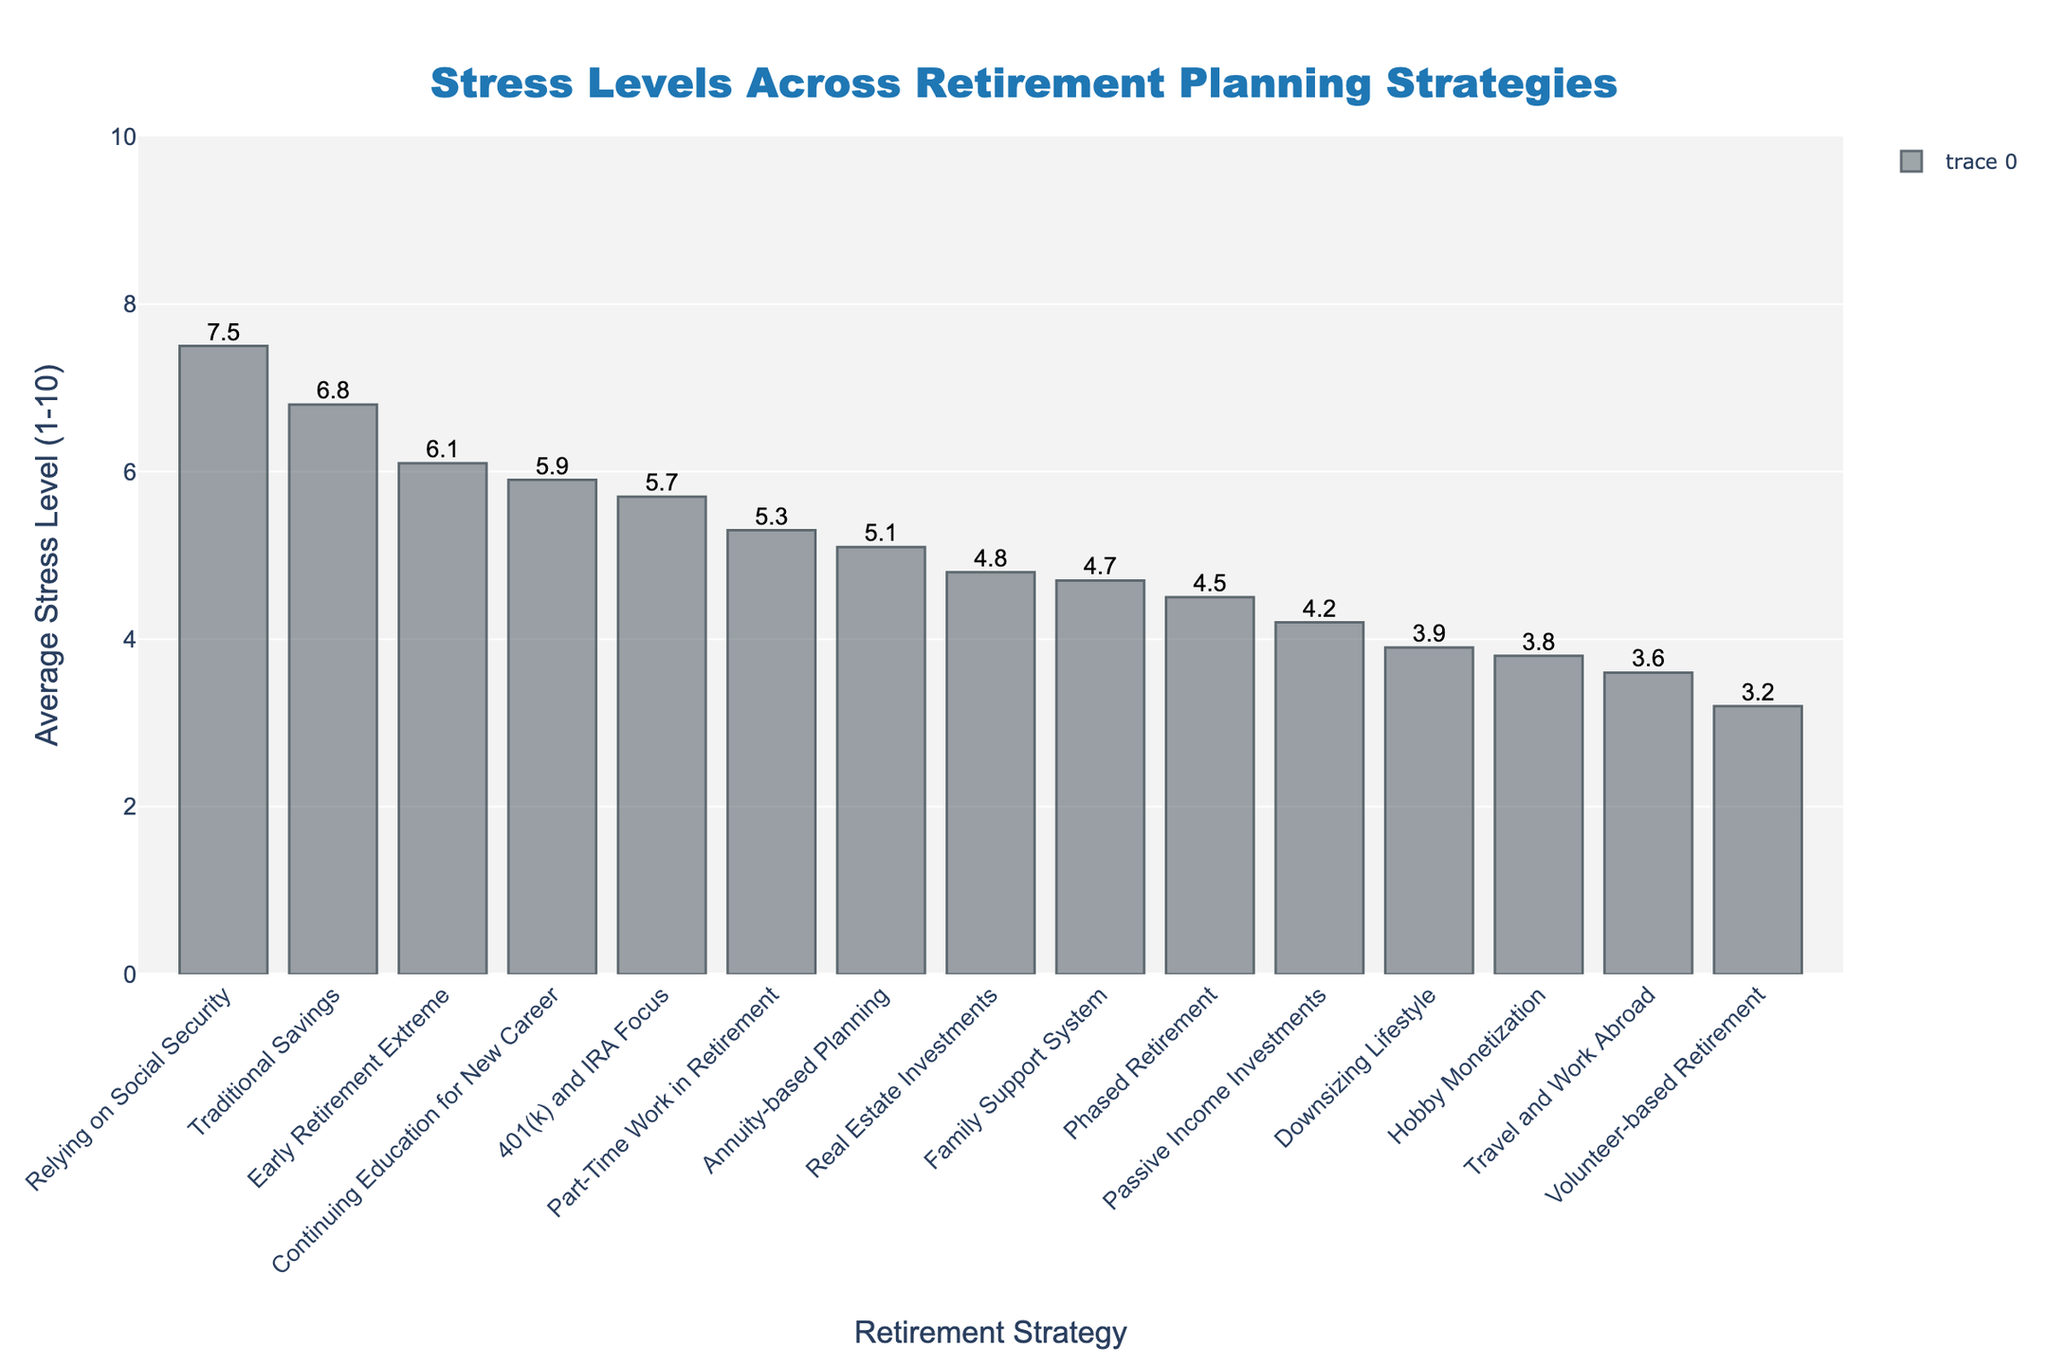Which retirement planning strategy has the highest average stress level? The "Relying on Social Security" strategy has the highest average stress level, indicated by the tallest bar in the chart.
Answer: Relying on Social Security What is the difference in average stress levels between "Relying on Social Security" and "Volunteer-based Retirement"? Find the stress levels for "Relying on Social Security" (7.5) and "Volunteer-based Retirement" (3.2), then subtract the latter from the former: 7.5 - 3.2 = 4.3.
Answer: 4.3 Which two strategies have the closest average stress levels? "Family Support System" and "Real Estate Investments" have stress levels of 4.7 and 4.8, respectively, making them the closest.
Answer: Family Support System and Real Estate Investments How many strategies have an average stress level below 5? Count the bars that are below the 5 mark on the y-axis: Passive Income Investments, Downsizing Lifestyle, Real Estate Investments, Phased Retirement, Travel and Work Abroad, Volunteer-based Retirement, Family Support System, and Hobby Monetization. There are 8 in total.
Answer: 8 What are the highest and the lowest stress levels represented in the chart? The highest stress level is 7.5 ("Relying on Social Security") and the lowest is 3.2 ("Volunteer-based Retirement").
Answer: 7.5 and 3.2 What is the sum of the average stress levels for "Traditional Savings", "Part-Time Work in Retirement", and "401(k) and IRA Focus"? Add the stress levels for these strategies: 6.8 (Traditional Savings) + 5.3 (Part-Time Work in Retirement) + 5.7 (401(k) and IRA Focus) = 17.8.
Answer: 17.8 Which strategy associated with an employment activity has the higher average stress level: "Part-Time Work in Retirement" or "Continuing Education for New Career"? Compare the stress levels: 5.3 for "Part-Time Work in Retirement" and 5.9 for "Continuing Education for New Career". The latter has a higher stress level.
Answer: Continuing Education for New Career What is the average of the average stress levels across all strategies? Sum all the stress levels and divide by the number of strategies. The sum is 79.0 and there are 15 strategies, so the average is 79.0 / 15 = 5.27.
Answer: 5.27 Which strategy associated with post-retirement travel has the lowest stress level? "Travel and Work Abroad" is the post-retirement travel strategy and has an average stress level of 3.6, lower than other travel-related strategies.
Answer: Travel and Work Abroad 